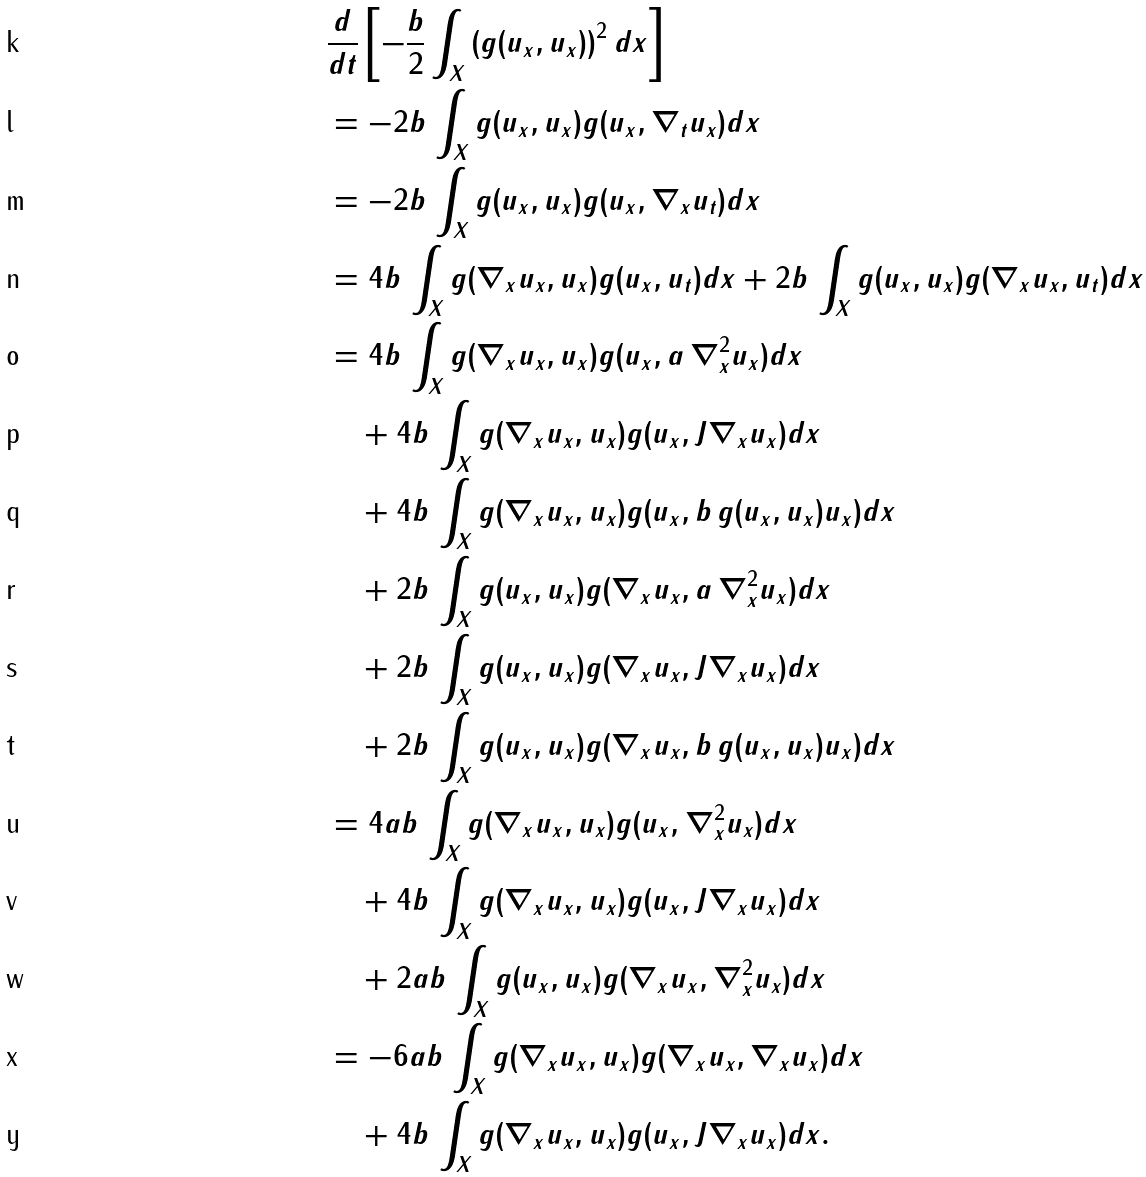Convert formula to latex. <formula><loc_0><loc_0><loc_500><loc_500>& \frac { d } { d t } \left [ - \frac { b } { 2 } \int _ { X } \left ( g ( u _ { x } , u _ { x } ) \right ) ^ { 2 } d x \right ] \\ & = - 2 b \, \int _ { X } g ( u _ { x } , u _ { x } ) g ( u _ { x } , \nabla _ { t } u _ { x } ) d x \\ & = - 2 b \, \int _ { X } g ( u _ { x } , u _ { x } ) g ( u _ { x } , \nabla _ { x } u _ { t } ) d x \\ & = 4 b \, \int _ { X } g ( \nabla _ { x } u _ { x } , u _ { x } ) g ( u _ { x } , u _ { t } ) d x + 2 b \, \int _ { X } g ( u _ { x } , u _ { x } ) g ( \nabla _ { x } u _ { x } , u _ { t } ) d x \\ & = 4 b \, \int _ { X } g ( \nabla _ { x } u _ { x } , u _ { x } ) g ( u _ { x } , a \, \nabla _ { x } ^ { 2 } u _ { x } ) d x \\ & \quad + 4 b \, \int _ { X } g ( \nabla _ { x } u _ { x } , u _ { x } ) g ( u _ { x } , J \nabla _ { x } u _ { x } ) d x \\ & \quad + 4 b \, \int _ { X } g ( \nabla _ { x } u _ { x } , u _ { x } ) g ( u _ { x } , b \, g ( u _ { x } , u _ { x } ) u _ { x } ) d x \\ & \quad + 2 b \, \int _ { X } g ( u _ { x } , u _ { x } ) g ( \nabla _ { x } u _ { x } , a \, \nabla _ { x } ^ { 2 } u _ { x } ) d x \\ & \quad + 2 b \, \int _ { X } g ( u _ { x } , u _ { x } ) g ( \nabla _ { x } u _ { x } , J \nabla _ { x } u _ { x } ) d x \\ & \quad + 2 b \, \int _ { X } g ( u _ { x } , u _ { x } ) g ( \nabla _ { x } u _ { x } , b \, g ( u _ { x } , u _ { x } ) u _ { x } ) d x \\ & = 4 a b \, \int _ { X } g ( \nabla _ { x } u _ { x } , u _ { x } ) g ( u _ { x } , \nabla _ { x } ^ { 2 } u _ { x } ) d x \\ & \quad + 4 b \, \int _ { X } g ( \nabla _ { x } u _ { x } , u _ { x } ) g ( u _ { x } , J \nabla _ { x } u _ { x } ) d x \\ & \quad + 2 a b \, \int _ { X } g ( u _ { x } , u _ { x } ) g ( \nabla _ { x } u _ { x } , \nabla _ { x } ^ { 2 } u _ { x } ) d x \\ & = - 6 a b \, \int _ { X } g ( \nabla _ { x } u _ { x } , u _ { x } ) g ( \nabla _ { x } u _ { x } , \nabla _ { x } u _ { x } ) d x \\ & \quad + 4 b \, \int _ { X } g ( \nabla _ { x } u _ { x } , u _ { x } ) g ( u _ { x } , J \nabla _ { x } u _ { x } ) d x .</formula> 